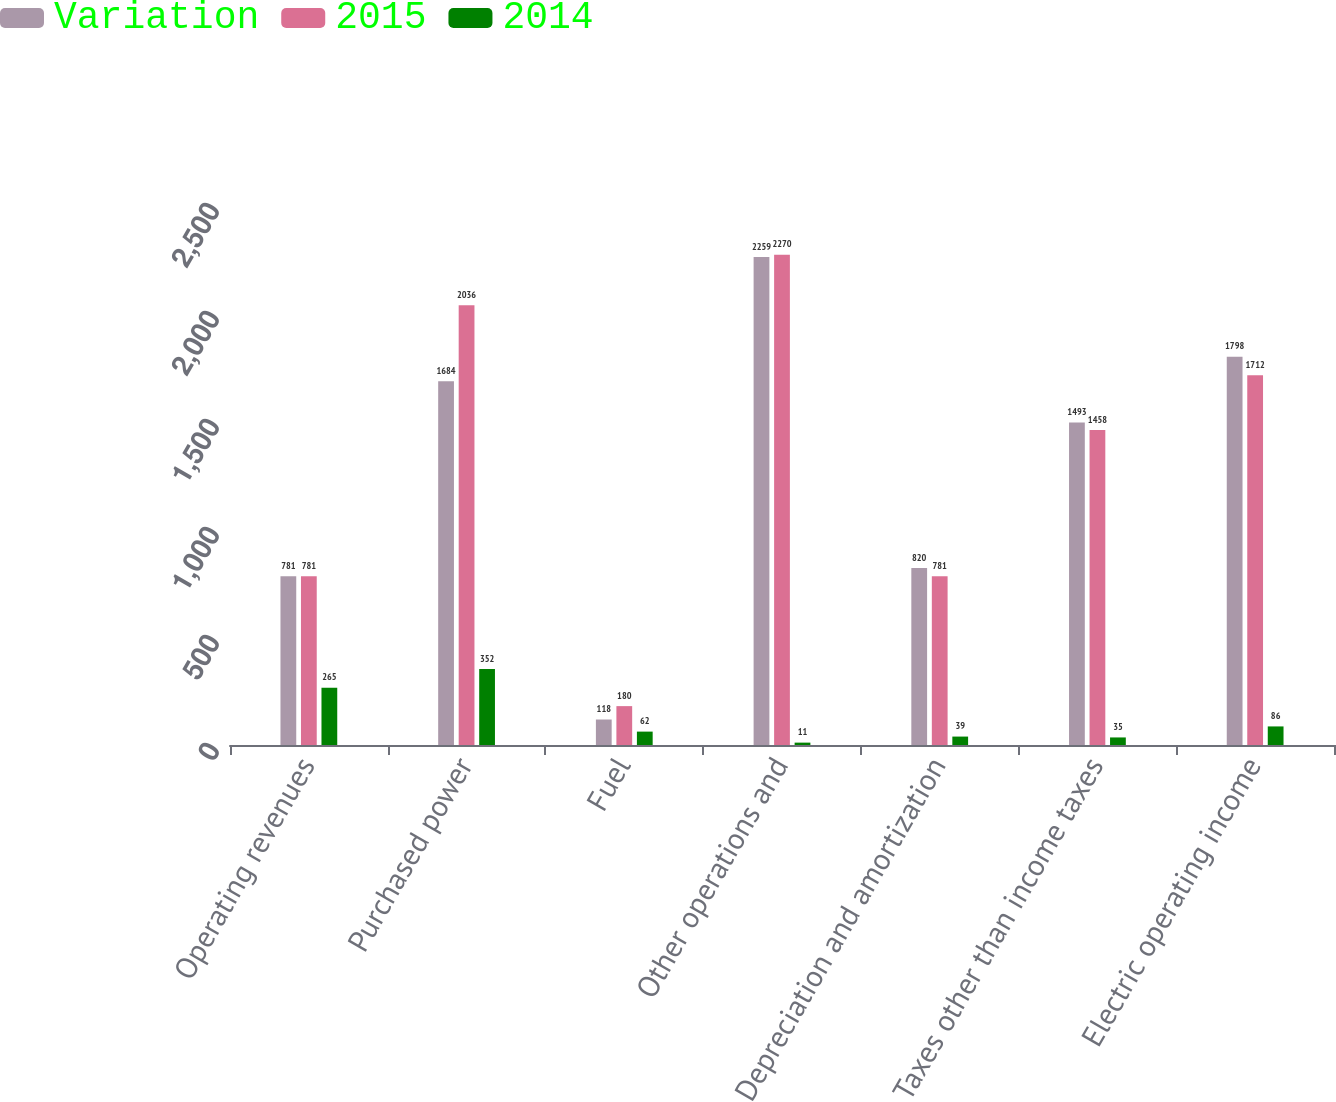Convert chart to OTSL. <chart><loc_0><loc_0><loc_500><loc_500><stacked_bar_chart><ecel><fcel>Operating revenues<fcel>Purchased power<fcel>Fuel<fcel>Other operations and<fcel>Depreciation and amortization<fcel>Taxes other than income taxes<fcel>Electric operating income<nl><fcel>Variation<fcel>781<fcel>1684<fcel>118<fcel>2259<fcel>820<fcel>1493<fcel>1798<nl><fcel>2015<fcel>781<fcel>2036<fcel>180<fcel>2270<fcel>781<fcel>1458<fcel>1712<nl><fcel>2014<fcel>265<fcel>352<fcel>62<fcel>11<fcel>39<fcel>35<fcel>86<nl></chart> 